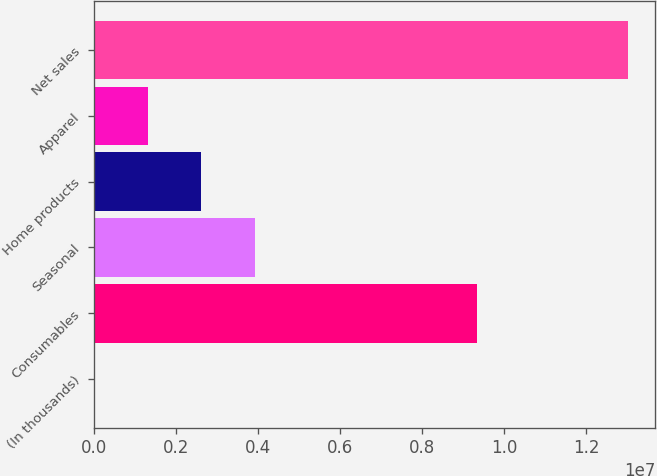Convert chart. <chart><loc_0><loc_0><loc_500><loc_500><bar_chart><fcel>(In thousands)<fcel>Consumables<fcel>Seasonal<fcel>Home products<fcel>Apparel<fcel>Net sales<nl><fcel>2010<fcel>9.33212e+06<fcel>3.91191e+06<fcel>2.60861e+06<fcel>1.30531e+06<fcel>1.3035e+07<nl></chart> 